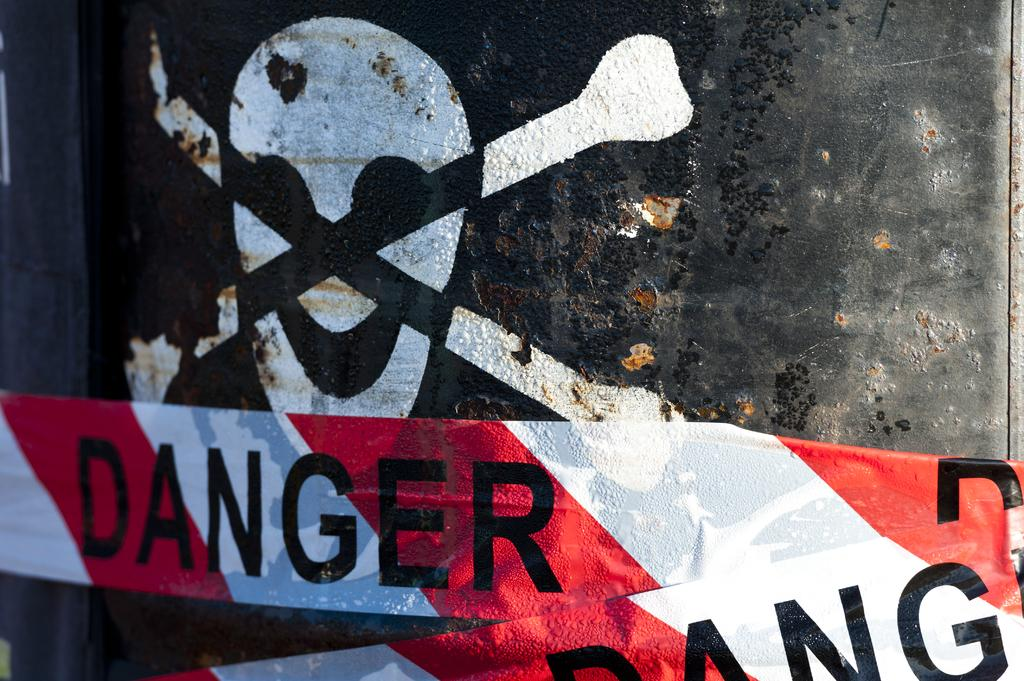What type of symbol is present in the image? There is a caution symbol in the image. What warning is conveyed by the bands in the image? The bands in the image have the word "danger" written on them, indicating a potential hazard. What type of weather is depicted in the image? There is no weather depicted in the image; it only contains a caution symbol and bands with the word "danger" written on them. 